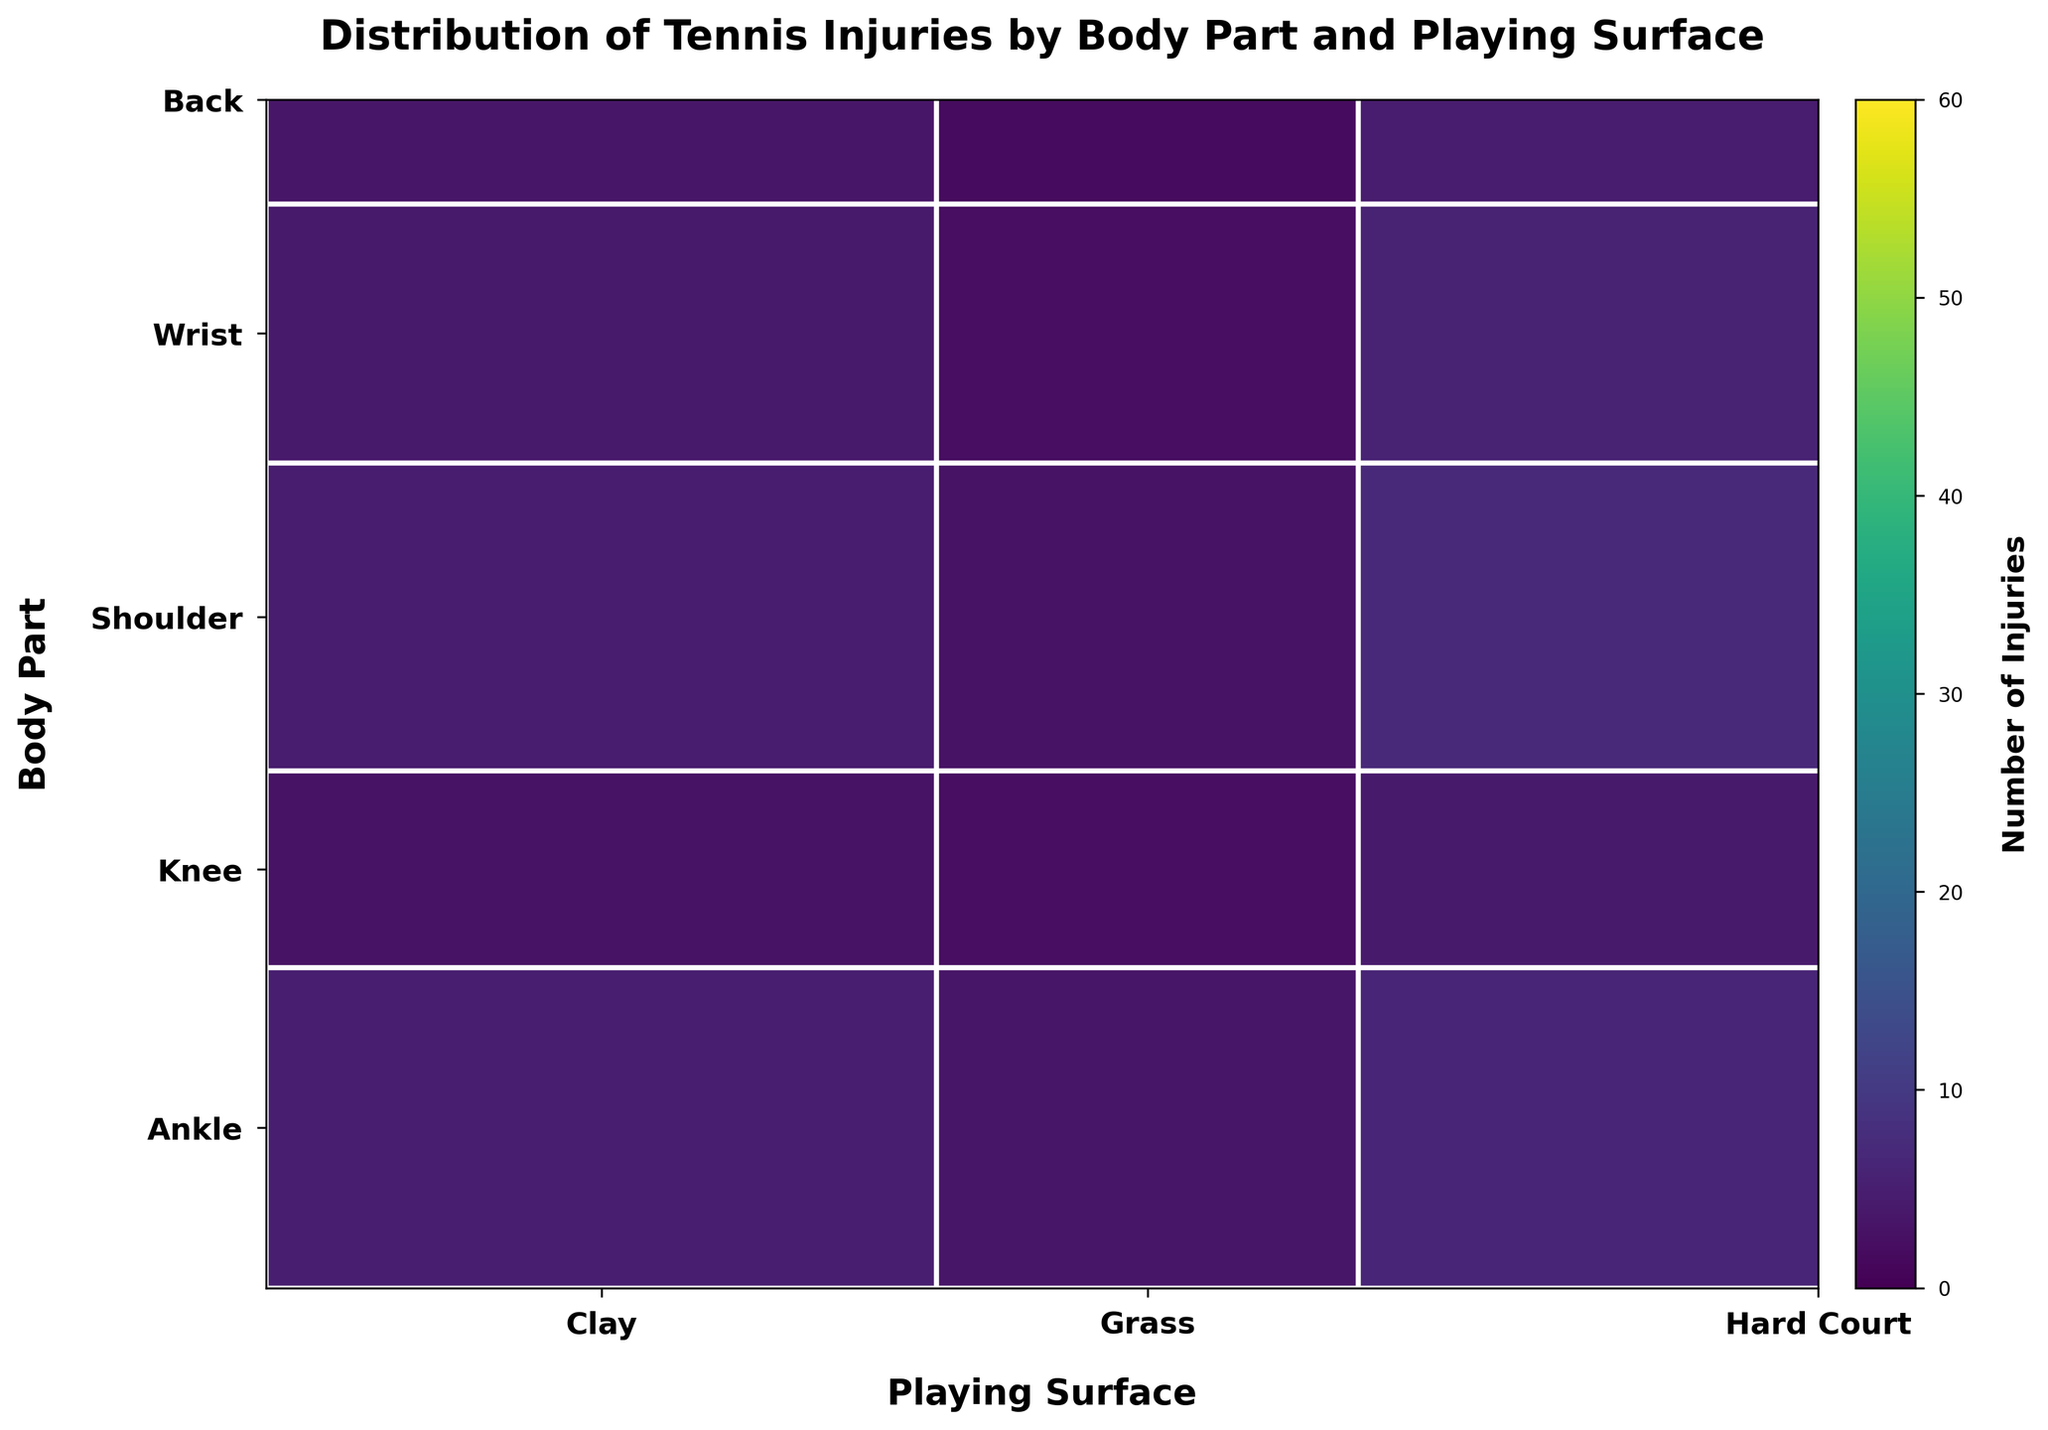Which playing surface has the highest total number of injuries? To find this, sum the injuries for each surface and see which is the highest. Adding up, Clay has 45+40+35+30+25 = 175, Grass has 30+25+20+15+20 = 110, and Hard Court has 55+60+50+40+35 = 240. Hard Court has the highest total number of injuries.
Answer: Hard Court Which body part has the lowest total number of injuries? Sum the injuries for each body part and compare. For Ankle: 45+30+55 = 130, Knee: 40+25+60 = 125, Shoulder: 35+20+50 = 105, Wrist: 30+15+40 = 85, Back: 25+20+35 = 80. Back has the lowest total number of injuries.
Answer: Back What is the color distribution among the different body parts? Look at the color shade in the mosaic plot for each body part. Darker shades generally represent higher injury counts. Visual inspection shows the colors vary from lighter in the Back row to darker shades in Ankle and Knee, as they have the highest injuries.
Answer: Darker for Ankle, Knee; lighter for Back, Wrist, Shoulder Which body part has the highest number of injuries on Hard Court? Check the Hard Court column to see which body part has the largest rectangle. For Hard Court, Ankle has 55, Knee has 60, Shoulder has 50, Wrist has 40, and Back has 35. Knee has the highest injuries on Hard Court.
Answer: Knee How many total injuries are there on Grass for all body parts combined? Sum the number of injuries for Grass across all body parts. Ankle has 30, Knee has 25, Shoulder has 20, Wrist has 15, Back has 20. Total is 30+25+20+15+20 = 110.
Answer: 110 Which color represents the highest number of injuries and on which surface? The highest number of injuries will be represented by the darkest shade in the color scale. The darkest color, representing the highest injury count, is in the Hard Court column for the Knee with 60 injuries.
Answer: Darkest color, Hard Court for Knee What is the total number of shoulder injuries on all surfaces combined? Add up the shoulder injuries for Clay, Grass, and Hard Court. Clay has 35, Grass has 20, Hard Court has 50. Total is 35+20+50 = 105.
Answer: 105 Which surface saw the least number of ankle injuries? Compare the number of ankle injuries across all surfaces. Clay has 45, Grass has 30, Hard Court has 55. Grass has the least number of ankle injuries.
Answer: Grass 